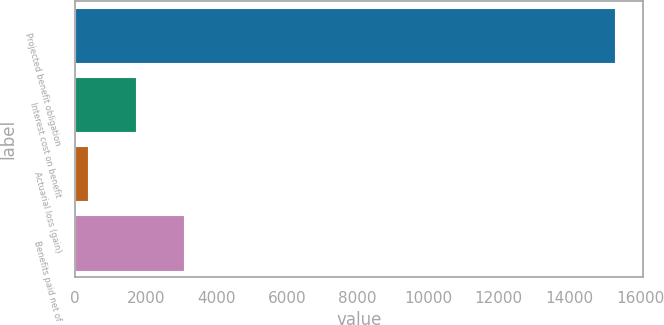Convert chart to OTSL. <chart><loc_0><loc_0><loc_500><loc_500><bar_chart><fcel>Projected benefit obligation<fcel>Interest cost on benefit<fcel>Actuarial loss (gain)<fcel>Benefits paid net of<nl><fcel>15306.3<fcel>1730.3<fcel>367<fcel>3093.6<nl></chart> 